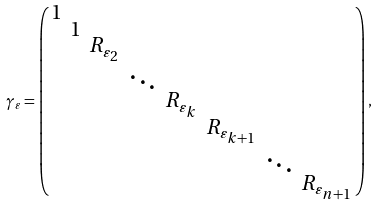Convert formula to latex. <formula><loc_0><loc_0><loc_500><loc_500>\gamma _ { \varepsilon } = \left ( \begin{smallmatrix} 1 \\ & 1 \\ & & R _ { \varepsilon _ { 2 } } \\ & & & \ddots \\ & & & & R _ { \varepsilon _ { k } } \\ & & & & & R _ { \varepsilon _ { k + 1 } } \\ & & & & & & \ddots \\ & & & & & & & R _ { \varepsilon _ { n + 1 } } \end{smallmatrix} \right ) ,</formula> 